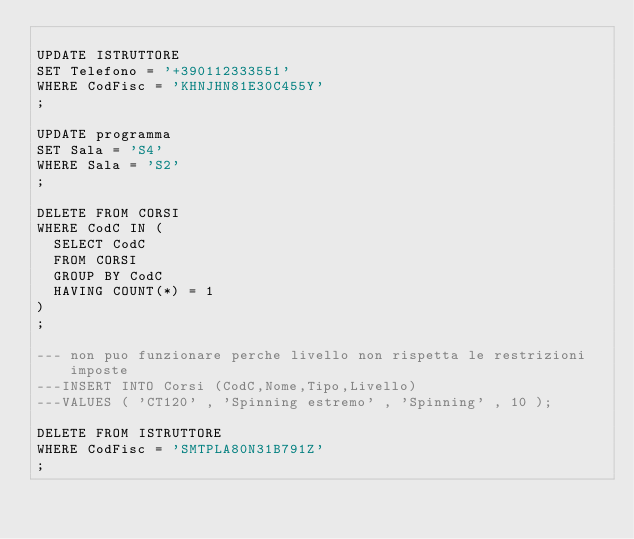<code> <loc_0><loc_0><loc_500><loc_500><_SQL_>
UPDATE ISTRUTTORE
SET Telefono = '+390112333551'
WHERE CodFisc = 'KHNJHN81E30C455Y'
;

UPDATE programma
SET Sala = 'S4'
WHERE Sala = 'S2'
;

DELETE FROM CORSI
WHERE CodC IN (
  SELECT CodC
  FROM CORSI
  GROUP BY CodC
  HAVING COUNT(*) = 1
)
;

--- non puo funzionare perche livello non rispetta le restrizioni imposte 
---INSERT INTO Corsi (CodC,Nome,Tipo,Livello)
---VALUES ( 'CT120' , 'Spinning estremo' , 'Spinning' , 10 );

DELETE FROM ISTRUTTORE
WHERE CodFisc = 'SMTPLA80N31B791Z'
;</code> 